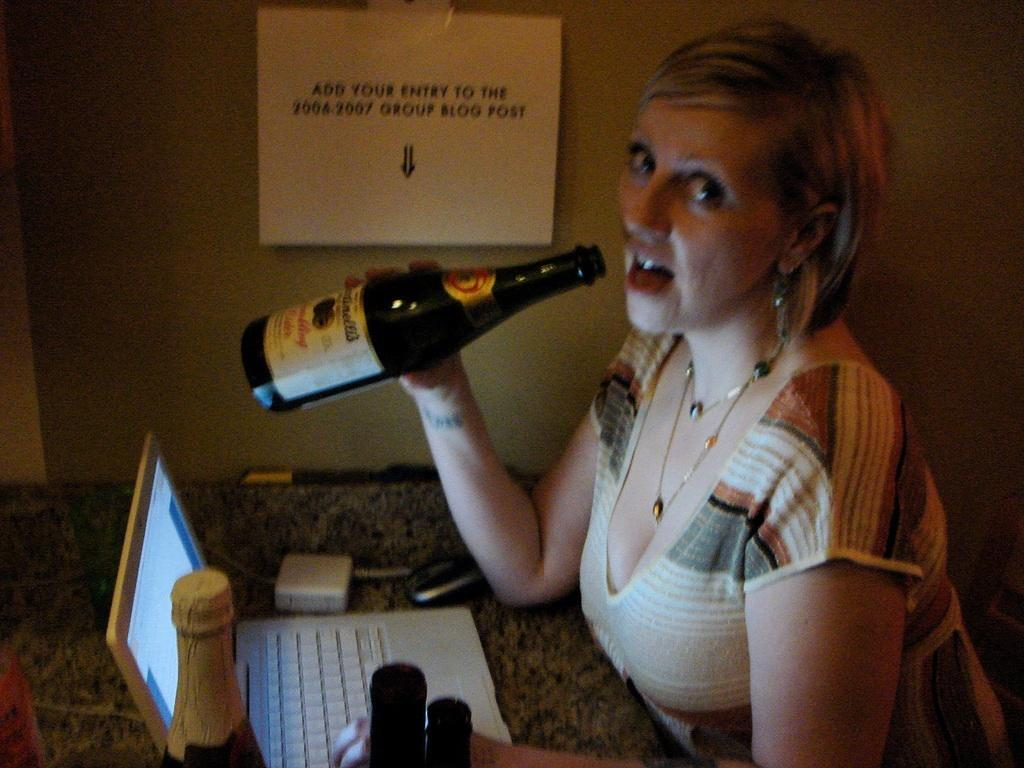Who is present in the image? There is a woman in the image. What is the woman doing in the image? The woman is seated on a chair. What is the woman holding in her hand? The woman is holding a beer bottle in her hand. How many bottles can be seen in the image? There are at least two bottles visible in the image. What object is on the table in the image? There is a laptop on the table. What type of apparatus is the woman using to communicate with others in the image? There is no apparatus visible in the image for communication purposes. What color is the dress the woman is wearing in the image? The provided facts do not mention the woman wearing a dress, so we cannot determine the color of a dress in the image. 